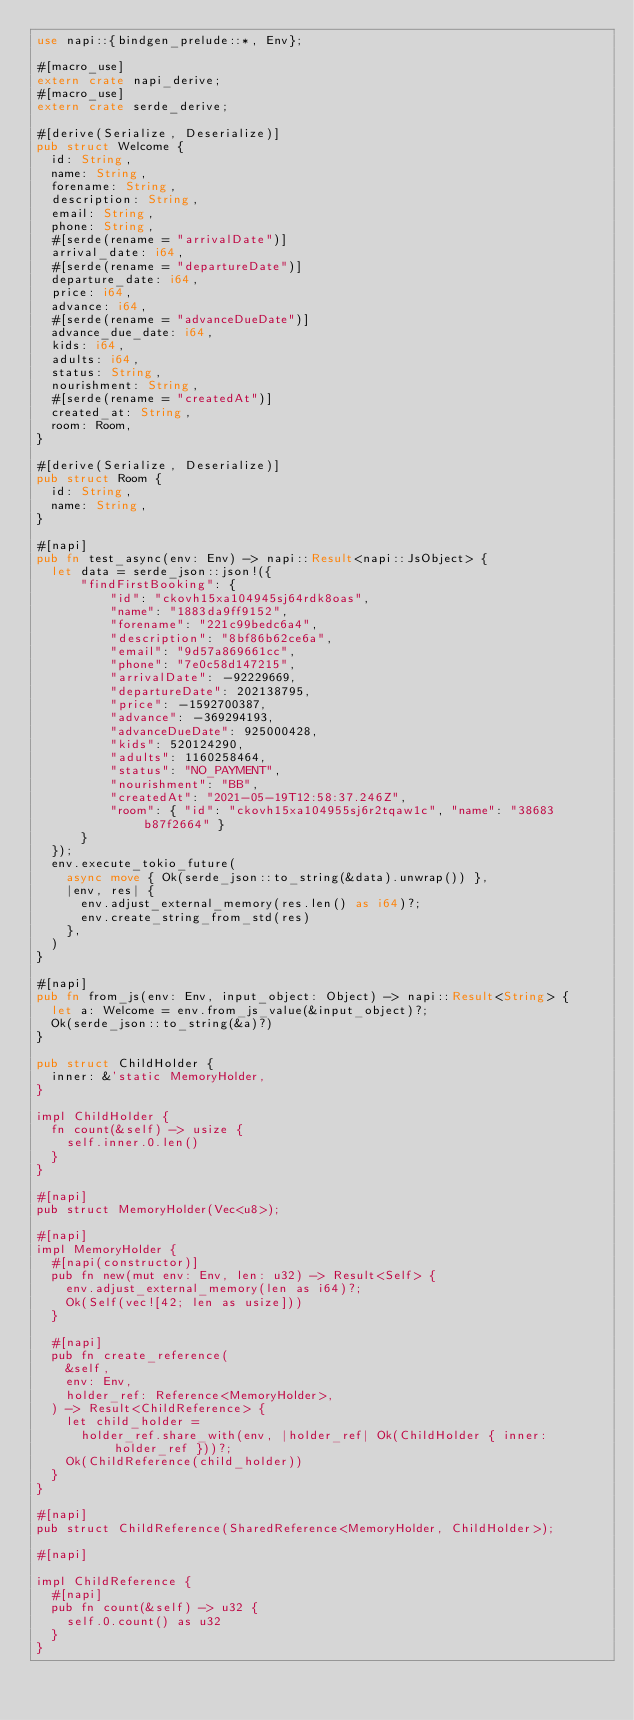Convert code to text. <code><loc_0><loc_0><loc_500><loc_500><_Rust_>use napi::{bindgen_prelude::*, Env};

#[macro_use]
extern crate napi_derive;
#[macro_use]
extern crate serde_derive;

#[derive(Serialize, Deserialize)]
pub struct Welcome {
  id: String,
  name: String,
  forename: String,
  description: String,
  email: String,
  phone: String,
  #[serde(rename = "arrivalDate")]
  arrival_date: i64,
  #[serde(rename = "departureDate")]
  departure_date: i64,
  price: i64,
  advance: i64,
  #[serde(rename = "advanceDueDate")]
  advance_due_date: i64,
  kids: i64,
  adults: i64,
  status: String,
  nourishment: String,
  #[serde(rename = "createdAt")]
  created_at: String,
  room: Room,
}

#[derive(Serialize, Deserialize)]
pub struct Room {
  id: String,
  name: String,
}

#[napi]
pub fn test_async(env: Env) -> napi::Result<napi::JsObject> {
  let data = serde_json::json!({
      "findFirstBooking": {
          "id": "ckovh15xa104945sj64rdk8oas",
          "name": "1883da9ff9152",
          "forename": "221c99bedc6a4",
          "description": "8bf86b62ce6a",
          "email": "9d57a869661cc",
          "phone": "7e0c58d147215",
          "arrivalDate": -92229669,
          "departureDate": 202138795,
          "price": -1592700387,
          "advance": -369294193,
          "advanceDueDate": 925000428,
          "kids": 520124290,
          "adults": 1160258464,
          "status": "NO_PAYMENT",
          "nourishment": "BB",
          "createdAt": "2021-05-19T12:58:37.246Z",
          "room": { "id": "ckovh15xa104955sj6r2tqaw1c", "name": "38683b87f2664" }
      }
  });
  env.execute_tokio_future(
    async move { Ok(serde_json::to_string(&data).unwrap()) },
    |env, res| {
      env.adjust_external_memory(res.len() as i64)?;
      env.create_string_from_std(res)
    },
  )
}

#[napi]
pub fn from_js(env: Env, input_object: Object) -> napi::Result<String> {
  let a: Welcome = env.from_js_value(&input_object)?;
  Ok(serde_json::to_string(&a)?)
}

pub struct ChildHolder {
  inner: &'static MemoryHolder,
}

impl ChildHolder {
  fn count(&self) -> usize {
    self.inner.0.len()
  }
}

#[napi]
pub struct MemoryHolder(Vec<u8>);

#[napi]
impl MemoryHolder {
  #[napi(constructor)]
  pub fn new(mut env: Env, len: u32) -> Result<Self> {
    env.adjust_external_memory(len as i64)?;
    Ok(Self(vec![42; len as usize]))
  }

  #[napi]
  pub fn create_reference(
    &self,
    env: Env,
    holder_ref: Reference<MemoryHolder>,
  ) -> Result<ChildReference> {
    let child_holder =
      holder_ref.share_with(env, |holder_ref| Ok(ChildHolder { inner: holder_ref }))?;
    Ok(ChildReference(child_holder))
  }
}

#[napi]
pub struct ChildReference(SharedReference<MemoryHolder, ChildHolder>);

#[napi]

impl ChildReference {
  #[napi]
  pub fn count(&self) -> u32 {
    self.0.count() as u32
  }
}
</code> 